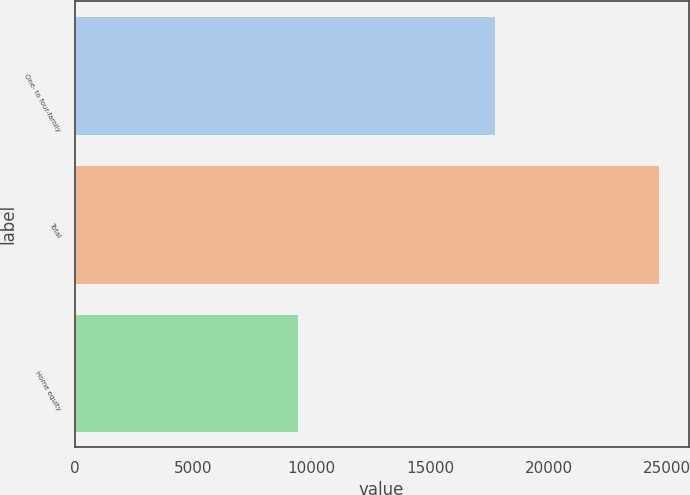Convert chart. <chart><loc_0><loc_0><loc_500><loc_500><bar_chart><fcel>One- to four-family<fcel>Total<fcel>Home equity<nl><fcel>17729<fcel>24661<fcel>9440<nl></chart> 